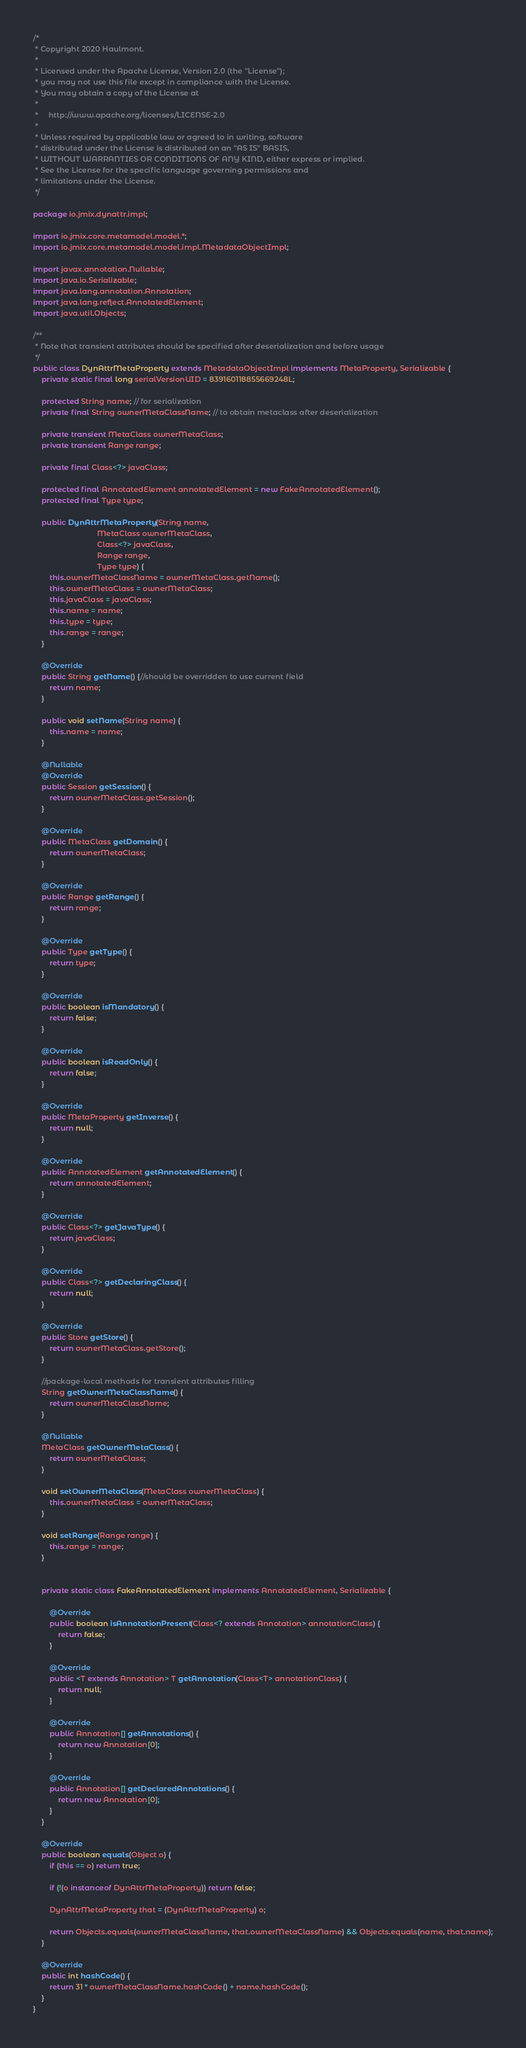Convert code to text. <code><loc_0><loc_0><loc_500><loc_500><_Java_>/*
 * Copyright 2020 Haulmont.
 *
 * Licensed under the Apache License, Version 2.0 (the "License");
 * you may not use this file except in compliance with the License.
 * You may obtain a copy of the License at
 *
 *     http://www.apache.org/licenses/LICENSE-2.0
 *
 * Unless required by applicable law or agreed to in writing, software
 * distributed under the License is distributed on an "AS IS" BASIS,
 * WITHOUT WARRANTIES OR CONDITIONS OF ANY KIND, either express or implied.
 * See the License for the specific language governing permissions and
 * limitations under the License.
 */

package io.jmix.dynattr.impl;

import io.jmix.core.metamodel.model.*;
import io.jmix.core.metamodel.model.impl.MetadataObjectImpl;

import javax.annotation.Nullable;
import java.io.Serializable;
import java.lang.annotation.Annotation;
import java.lang.reflect.AnnotatedElement;
import java.util.Objects;

/**
 * Note that transient attributes should be specified after deserialization and before usage
 */
public class DynAttrMetaProperty extends MetadataObjectImpl implements MetaProperty, Serializable {
    private static final long serialVersionUID = 839160118855669248L;

    protected String name; // for serialization
    private final String ownerMetaClassName; // to obtain metaclass after deserialization

    private transient MetaClass ownerMetaClass;
    private transient Range range;

    private final Class<?> javaClass;

    protected final AnnotatedElement annotatedElement = new FakeAnnotatedElement();
    protected final Type type;

    public DynAttrMetaProperty(String name,
                               MetaClass ownerMetaClass,
                               Class<?> javaClass,
                               Range range,
                               Type type) {
        this.ownerMetaClassName = ownerMetaClass.getName();
        this.ownerMetaClass = ownerMetaClass;
        this.javaClass = javaClass;
        this.name = name;
        this.type = type;
        this.range = range;
    }

    @Override
    public String getName() {//should be overridden to use current field
        return name;
    }

    public void setName(String name) {
        this.name = name;
    }

    @Nullable
    @Override
    public Session getSession() {
        return ownerMetaClass.getSession();
    }

    @Override
    public MetaClass getDomain() {
        return ownerMetaClass;
    }

    @Override
    public Range getRange() {
        return range;
    }

    @Override
    public Type getType() {
        return type;
    }

    @Override
    public boolean isMandatory() {
        return false;
    }

    @Override
    public boolean isReadOnly() {
        return false;
    }

    @Override
    public MetaProperty getInverse() {
        return null;
    }

    @Override
    public AnnotatedElement getAnnotatedElement() {
        return annotatedElement;
    }

    @Override
    public Class<?> getJavaType() {
        return javaClass;
    }

    @Override
    public Class<?> getDeclaringClass() {
        return null;
    }

    @Override
    public Store getStore() {
        return ownerMetaClass.getStore();
    }

    //package-local methods for transient attributes filling
    String getOwnerMetaClassName() {
        return ownerMetaClassName;
    }

    @Nullable
    MetaClass getOwnerMetaClass() {
        return ownerMetaClass;
    }

    void setOwnerMetaClass(MetaClass ownerMetaClass) {
        this.ownerMetaClass = ownerMetaClass;
    }

    void setRange(Range range) {
        this.range = range;
    }


    private static class FakeAnnotatedElement implements AnnotatedElement, Serializable {

        @Override
        public boolean isAnnotationPresent(Class<? extends Annotation> annotationClass) {
            return false;
        }

        @Override
        public <T extends Annotation> T getAnnotation(Class<T> annotationClass) {
            return null;
        }

        @Override
        public Annotation[] getAnnotations() {
            return new Annotation[0];
        }

        @Override
        public Annotation[] getDeclaredAnnotations() {
            return new Annotation[0];
        }
    }

    @Override
    public boolean equals(Object o) {
        if (this == o) return true;

        if (!(o instanceof DynAttrMetaProperty)) return false;

        DynAttrMetaProperty that = (DynAttrMetaProperty) o;

        return Objects.equals(ownerMetaClassName, that.ownerMetaClassName) && Objects.equals(name, that.name);
    }

    @Override
    public int hashCode() {
        return 31 * ownerMetaClassName.hashCode() + name.hashCode();
    }
}
</code> 